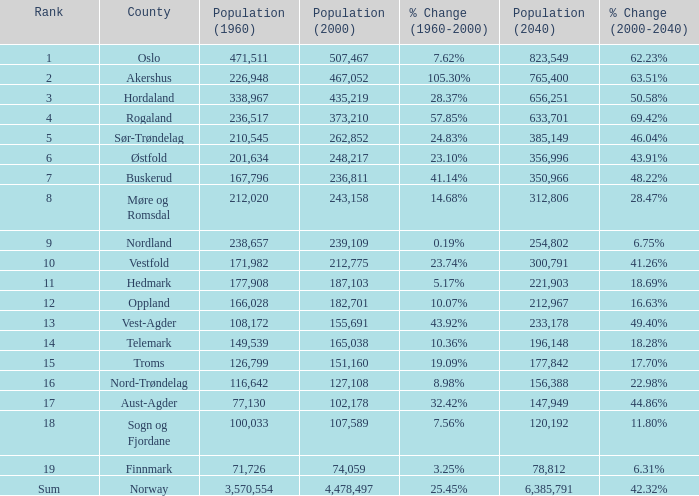What was the population of a county in 2040 that had a population less than 108,172 in 2000 and less than 107,589 in 1960? 2.0. 